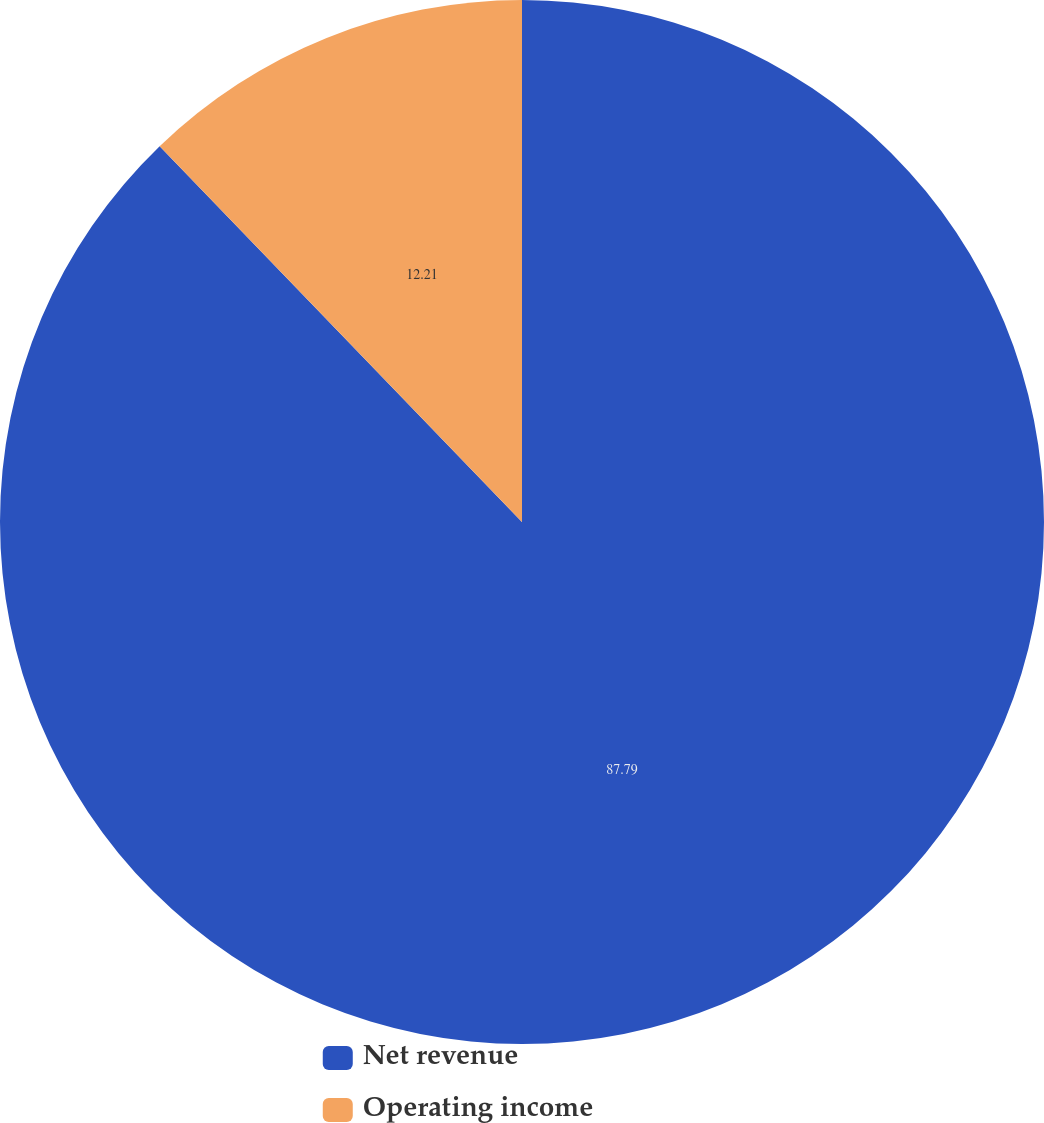<chart> <loc_0><loc_0><loc_500><loc_500><pie_chart><fcel>Net revenue<fcel>Operating income<nl><fcel>87.79%<fcel>12.21%<nl></chart> 